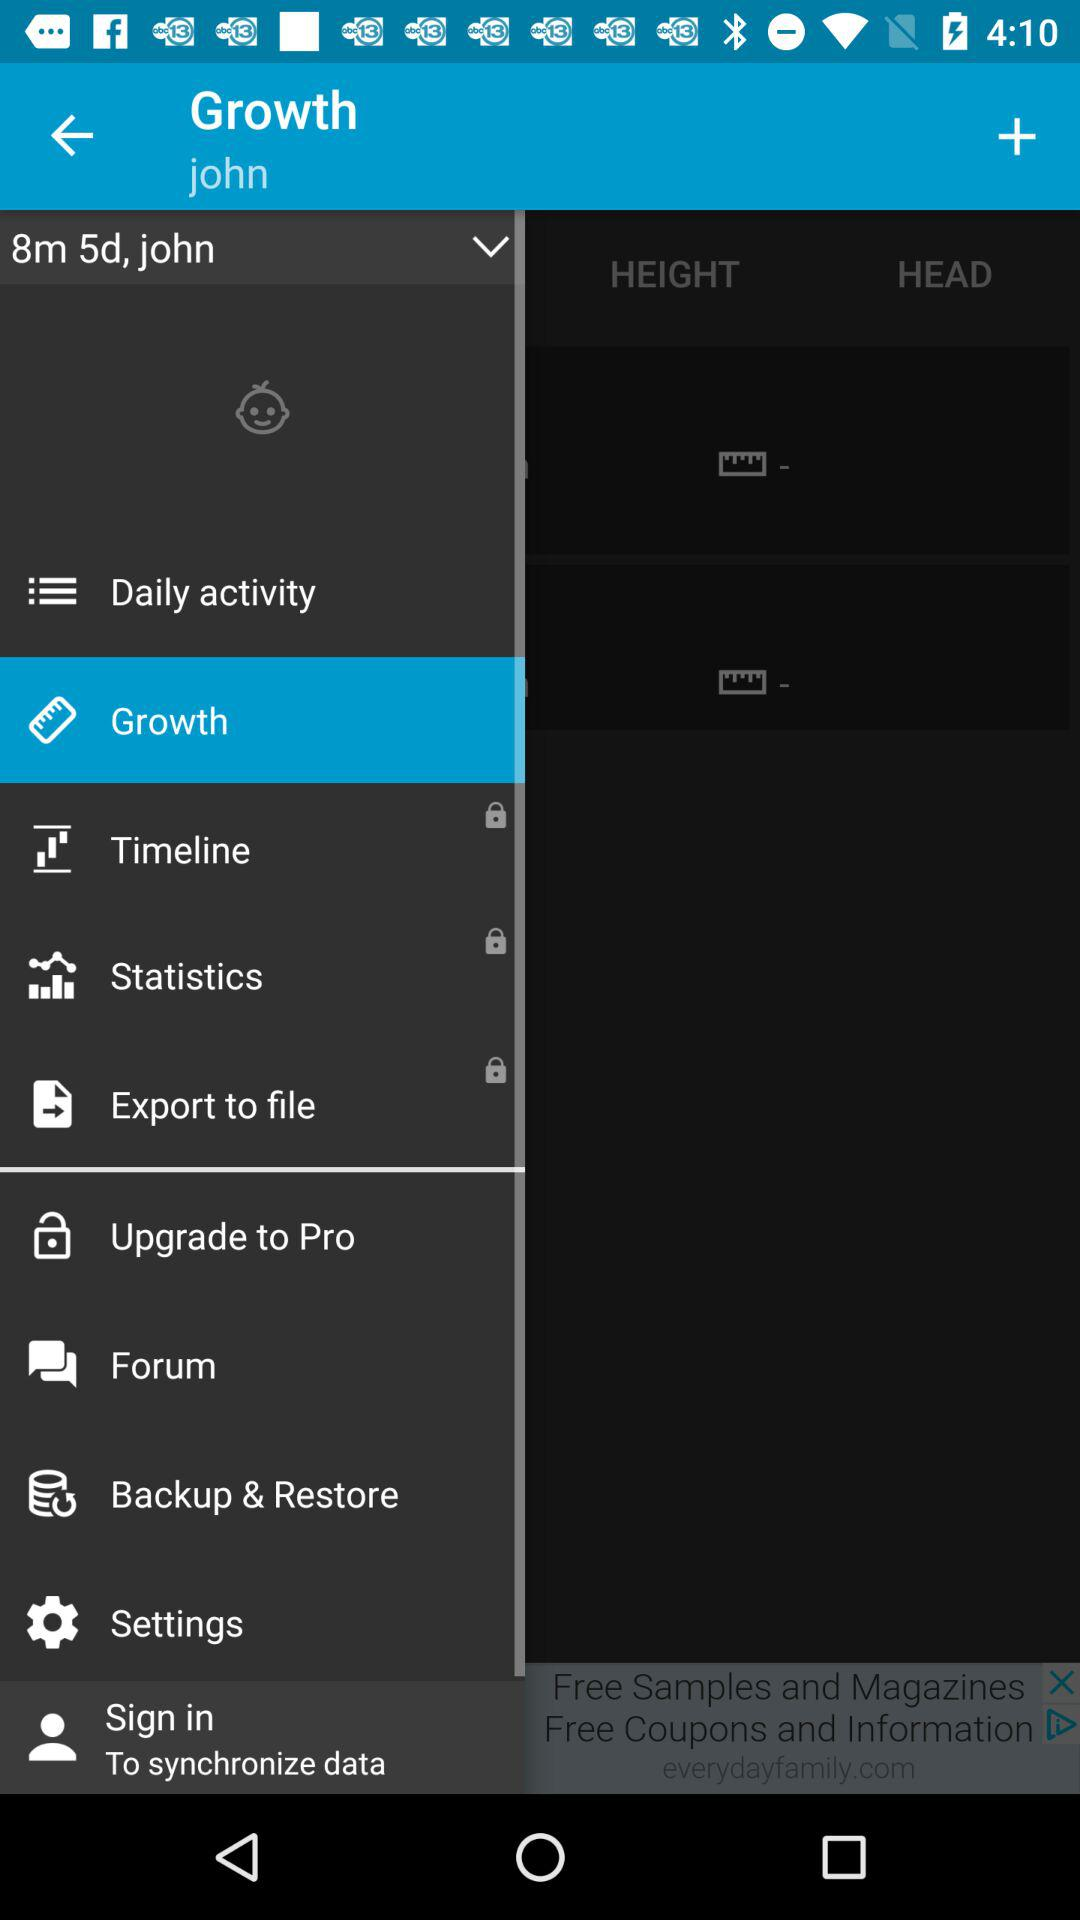What is the age of the user? The age of the user is 8 months and 5 days. 